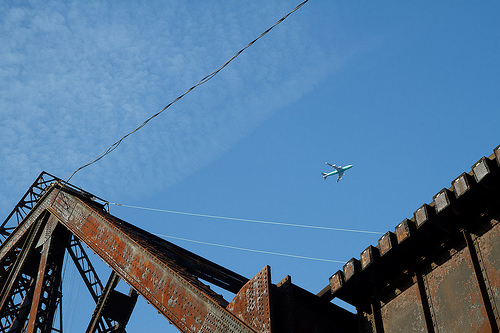Please provide a short description for this region: [0.26, 0.44, 0.4, 0.55]. Puffy white clouds floating in a clear blue sky. 